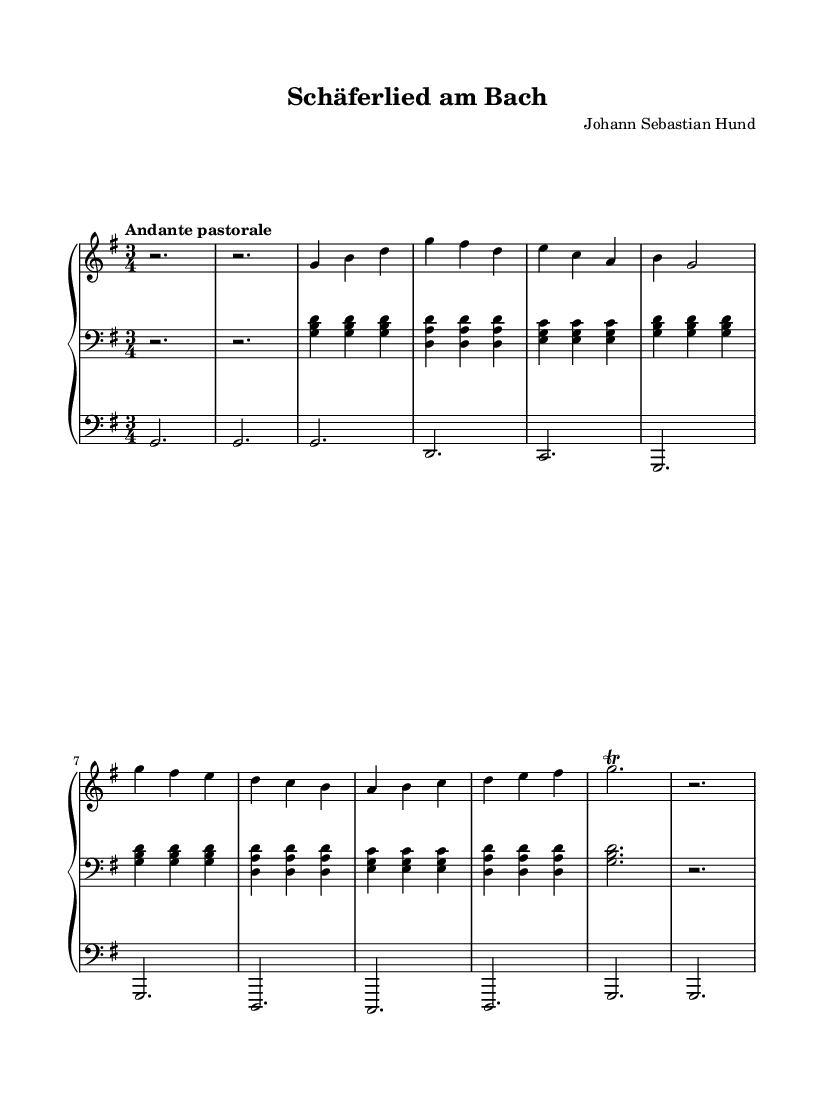What is the key signature of this music? The key signature is G major, which has one sharp (F#). This is indicated at the beginning of the staff in the key signature area.
Answer: G major What is the time signature of this music? The time signature is 3/4, meaning there are three beats in each measure, and the quarter note receives one beat. This is seen at the beginning of the score in the time signature area.
Answer: 3/4 What is the tempo marking of this music? The tempo marking is "Andante pastorale," indicating a moderately slow pace with a pastoral feel. This is indicated above the staff near the beginning of the sheet music.
Answer: Andante pastorale How many measures are there in the main theme section? The main theme has four measures. This can be counted from the beginning of the main theme to the end, observing the bar lines that separate the measures.
Answer: Four What is the structure of this composition? The structure includes a Prelude, Main Theme, Variation, and Coda. This can be inferred from the notation and spacing in the sheet music, which outlines these distinct sections.
Answer: Prelude, Main Theme, Variation, Coda What instruments are written for in this composition? The composition is written for a church organ, as indicated by the annotations for the MIDI instruments next to each staff.
Answer: Church organ What type of musical decoration is used at the end of the Coda? The musical decoration used at the end of the Coda is a trill, which is shown as a specific marking above the note. This decorative ornamentation indicates a rapid alternation between adjacent notes.
Answer: Trill 